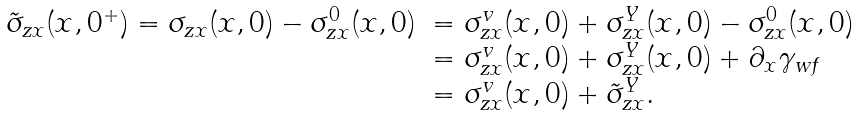<formula> <loc_0><loc_0><loc_500><loc_500>\begin{array} { l l l } \tilde { \sigma } _ { z x } ( x , 0 ^ { + } ) = \sigma _ { z x } ( x , 0 ) - \sigma _ { z x } ^ { 0 } ( x , 0 ) & = \sigma _ { z x } ^ { v } ( x , 0 ) + \sigma _ { z x } ^ { Y } ( x , 0 ) - \sigma _ { z x } ^ { 0 } ( x , 0 ) \\ & = \sigma _ { z x } ^ { v } ( x , 0 ) + \sigma _ { z x } ^ { Y } ( x , 0 ) + \partial _ { x } \gamma _ { w f } \\ & = \sigma _ { z x } ^ { v } ( x , 0 ) + \tilde { \sigma } _ { z x } ^ { Y } . \end{array}</formula> 